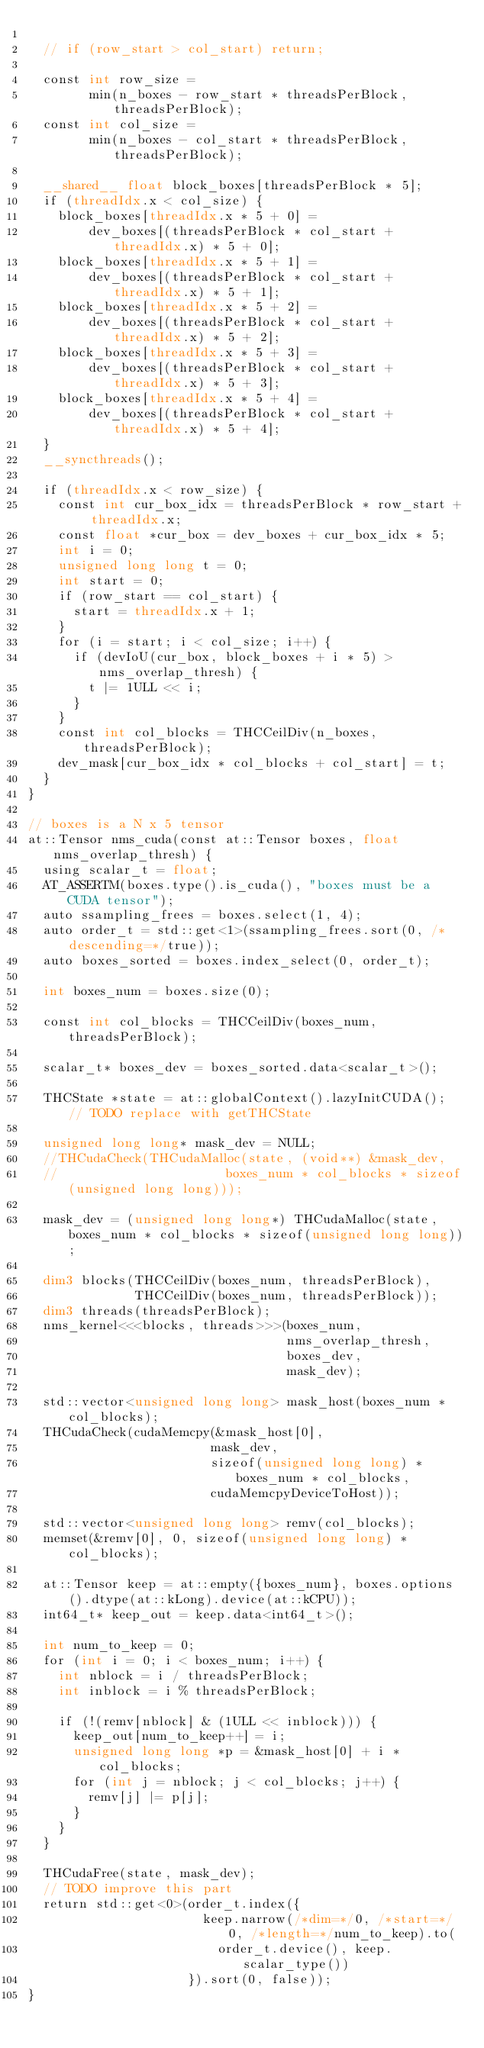<code> <loc_0><loc_0><loc_500><loc_500><_Cuda_>
  // if (row_start > col_start) return;

  const int row_size =
        min(n_boxes - row_start * threadsPerBlock, threadsPerBlock);
  const int col_size =
        min(n_boxes - col_start * threadsPerBlock, threadsPerBlock);

  __shared__ float block_boxes[threadsPerBlock * 5];
  if (threadIdx.x < col_size) {
    block_boxes[threadIdx.x * 5 + 0] =
        dev_boxes[(threadsPerBlock * col_start + threadIdx.x) * 5 + 0];
    block_boxes[threadIdx.x * 5 + 1] =
        dev_boxes[(threadsPerBlock * col_start + threadIdx.x) * 5 + 1];
    block_boxes[threadIdx.x * 5 + 2] =
        dev_boxes[(threadsPerBlock * col_start + threadIdx.x) * 5 + 2];
    block_boxes[threadIdx.x * 5 + 3] =
        dev_boxes[(threadsPerBlock * col_start + threadIdx.x) * 5 + 3];
    block_boxes[threadIdx.x * 5 + 4] =
        dev_boxes[(threadsPerBlock * col_start + threadIdx.x) * 5 + 4];
  }
  __syncthreads();

  if (threadIdx.x < row_size) {
    const int cur_box_idx = threadsPerBlock * row_start + threadIdx.x;
    const float *cur_box = dev_boxes + cur_box_idx * 5;
    int i = 0;
    unsigned long long t = 0;
    int start = 0;
    if (row_start == col_start) {
      start = threadIdx.x + 1;
    }
    for (i = start; i < col_size; i++) {
      if (devIoU(cur_box, block_boxes + i * 5) > nms_overlap_thresh) {
        t |= 1ULL << i;
      }
    }
    const int col_blocks = THCCeilDiv(n_boxes, threadsPerBlock);
    dev_mask[cur_box_idx * col_blocks + col_start] = t;
  }
}

// boxes is a N x 5 tensor
at::Tensor nms_cuda(const at::Tensor boxes, float nms_overlap_thresh) {
  using scalar_t = float;
  AT_ASSERTM(boxes.type().is_cuda(), "boxes must be a CUDA tensor");
  auto ssampling_frees = boxes.select(1, 4);
  auto order_t = std::get<1>(ssampling_frees.sort(0, /* descending=*/true));
  auto boxes_sorted = boxes.index_select(0, order_t);

  int boxes_num = boxes.size(0);

  const int col_blocks = THCCeilDiv(boxes_num, threadsPerBlock);

  scalar_t* boxes_dev = boxes_sorted.data<scalar_t>();

  THCState *state = at::globalContext().lazyInitCUDA(); // TODO replace with getTHCState

  unsigned long long* mask_dev = NULL;
  //THCudaCheck(THCudaMalloc(state, (void**) &mask_dev,
  //                      boxes_num * col_blocks * sizeof(unsigned long long)));

  mask_dev = (unsigned long long*) THCudaMalloc(state, boxes_num * col_blocks * sizeof(unsigned long long));

  dim3 blocks(THCCeilDiv(boxes_num, threadsPerBlock),
              THCCeilDiv(boxes_num, threadsPerBlock));
  dim3 threads(threadsPerBlock);
  nms_kernel<<<blocks, threads>>>(boxes_num,
                                  nms_overlap_thresh,
                                  boxes_dev,
                                  mask_dev);

  std::vector<unsigned long long> mask_host(boxes_num * col_blocks);
  THCudaCheck(cudaMemcpy(&mask_host[0],
                        mask_dev,
                        sizeof(unsigned long long) * boxes_num * col_blocks,
                        cudaMemcpyDeviceToHost));

  std::vector<unsigned long long> remv(col_blocks);
  memset(&remv[0], 0, sizeof(unsigned long long) * col_blocks);

  at::Tensor keep = at::empty({boxes_num}, boxes.options().dtype(at::kLong).device(at::kCPU));
  int64_t* keep_out = keep.data<int64_t>();

  int num_to_keep = 0;
  for (int i = 0; i < boxes_num; i++) {
    int nblock = i / threadsPerBlock;
    int inblock = i % threadsPerBlock;

    if (!(remv[nblock] & (1ULL << inblock))) {
      keep_out[num_to_keep++] = i;
      unsigned long long *p = &mask_host[0] + i * col_blocks;
      for (int j = nblock; j < col_blocks; j++) {
        remv[j] |= p[j];
      }
    }
  }

  THCudaFree(state, mask_dev);
  // TODO improve this part
  return std::get<0>(order_t.index({
                       keep.narrow(/*dim=*/0, /*start=*/0, /*length=*/num_to_keep).to(
                         order_t.device(), keep.scalar_type())
                     }).sort(0, false));
}
</code> 